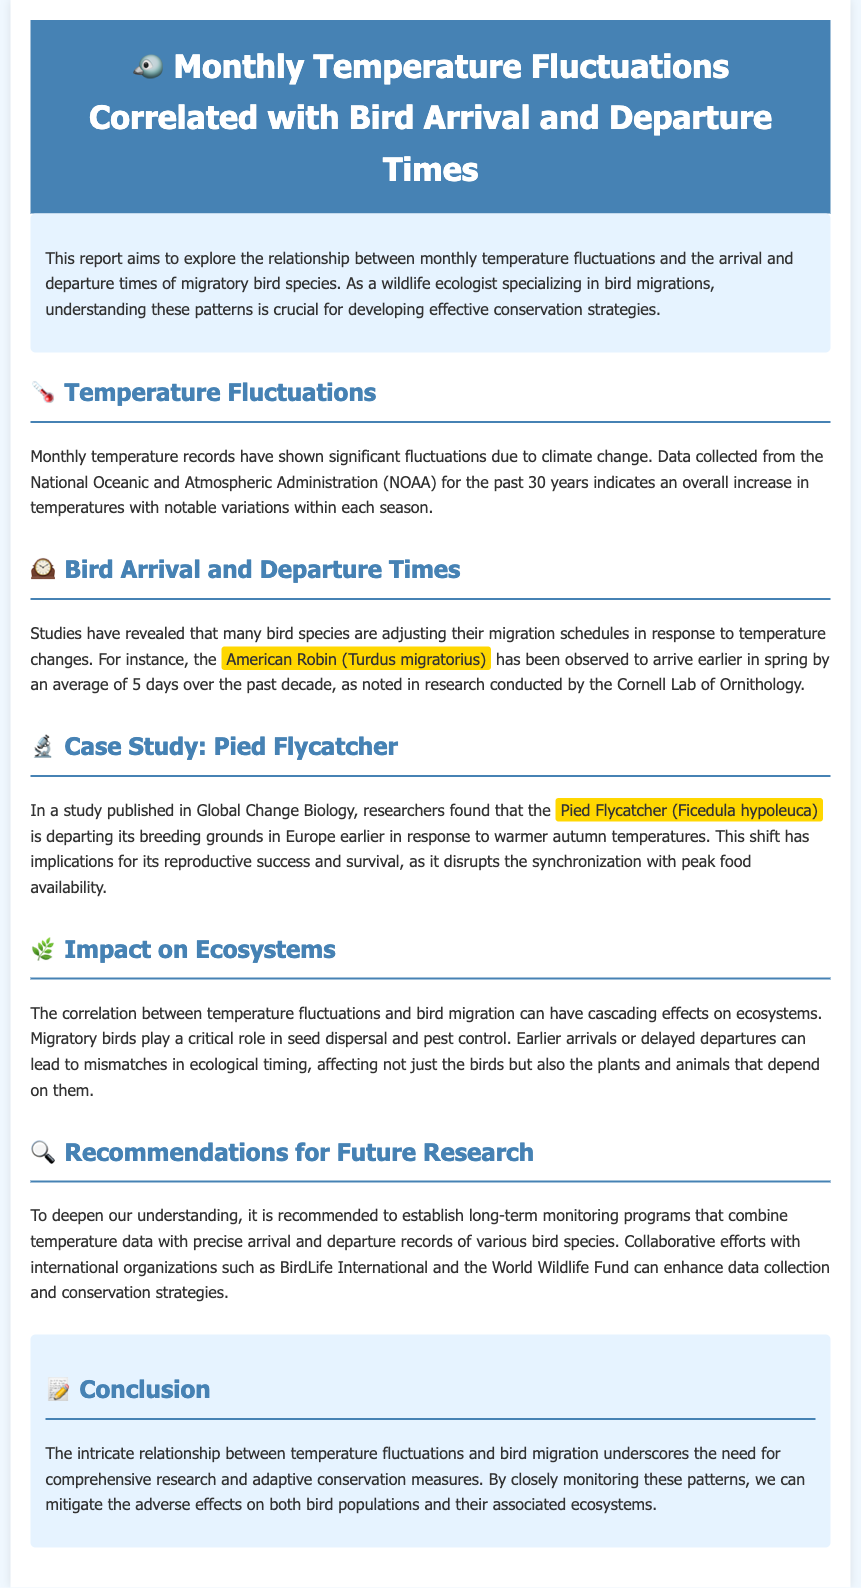What is the main focus of the report? The report aims to explore the relationship between monthly temperature fluctuations and the arrival and departure times of migratory bird species.
Answer: relationship between temperature fluctuations and bird migration Which bird species is mentioned as arriving earlier in spring? The report notes that the American Robin has been observed to arrive earlier in spring by an average of 5 days.
Answer: American Robin What significant change in the Pied Flycatcher's behavior is highlighted? The report highlights that the Pied Flycatcher is departing its breeding grounds earlier in response to warmer autumn temperatures.
Answer: departing earlier What role do migratory birds play in ecosystems? The document states that migratory birds play a critical role in seed dispersal and pest control.
Answer: seed dispersal and pest control What does the report recommend for future research? The report recommends establishing long-term monitoring programs that combine temperature data with precise arrival and departure records of various bird species.
Answer: long-term monitoring programs How long has temperature data been collected? The document mentions that data has been collected for the past 30 years.
Answer: past 30 years Who conducted the research on the American Robin's arrival timing? The report acknowledges the research conducted by the Cornell Lab of Ornithology.
Answer: Cornell Lab of Ornithology What are the implications of mismatches in ecological timing? The document mentions that mismatches can affect not just the birds but also the plants and animals that depend on them.
Answer: affect plants and animals 